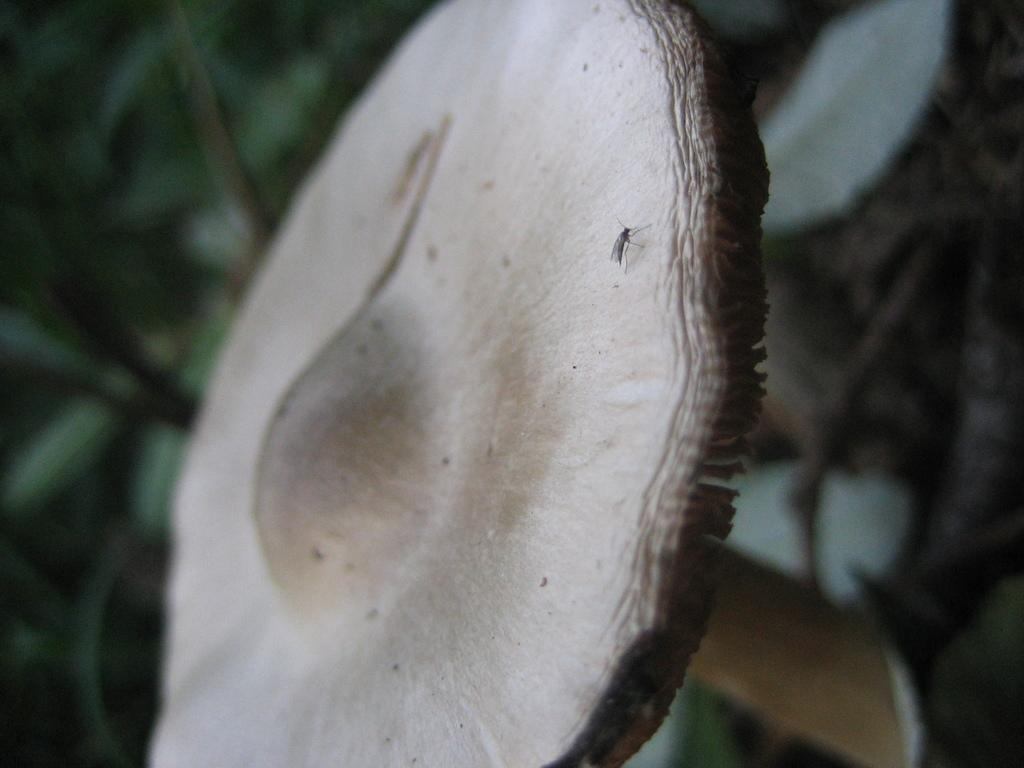What type of plant is depicted in the image? The plant resembles a mushroom in the image. Are there any other living organisms present on the plant? Yes, there is a mosquito on the plant. Can you describe the background of the image? The background of the image is blurred. What type of event is taking place in the image? There is no event depicted in the image; it features a plant that resembles a mushroom with a mosquito on it and a blurred background. How does the mosquito look in the image? The mosquito is present on the plant in the image, but there is no information about its appearance provided in the facts. 